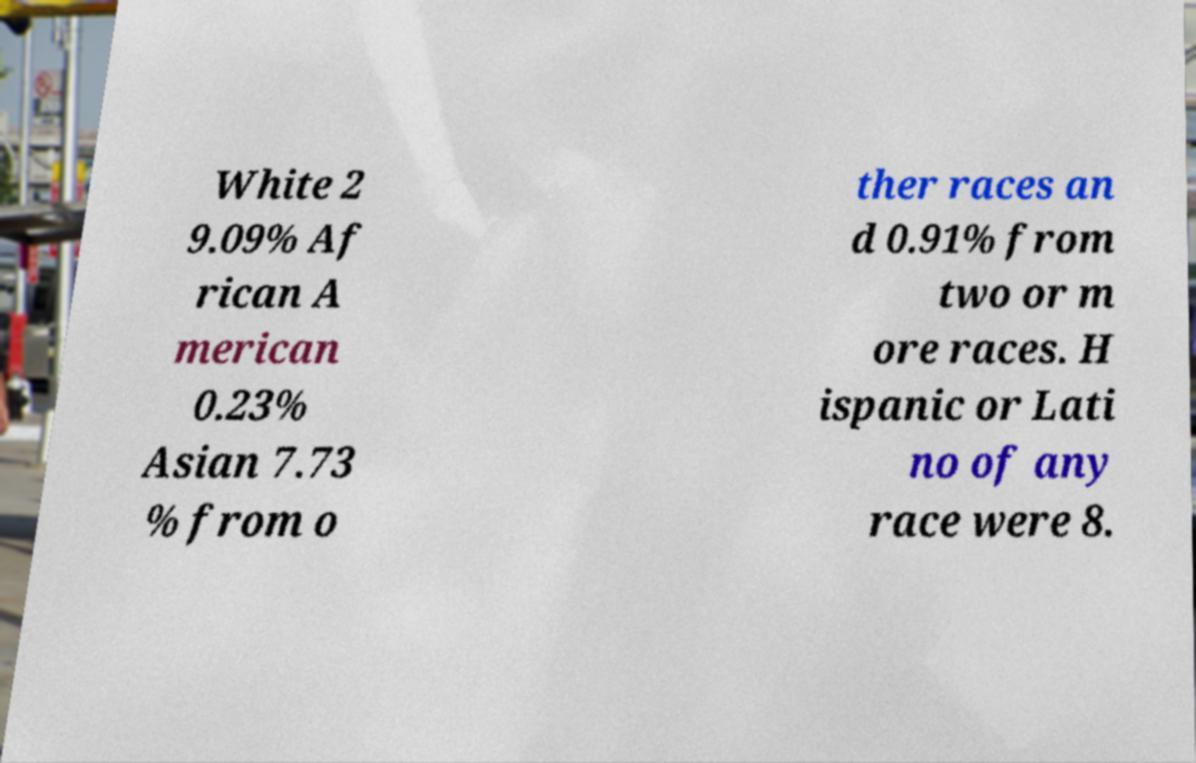Could you assist in decoding the text presented in this image and type it out clearly? White 2 9.09% Af rican A merican 0.23% Asian 7.73 % from o ther races an d 0.91% from two or m ore races. H ispanic or Lati no of any race were 8. 